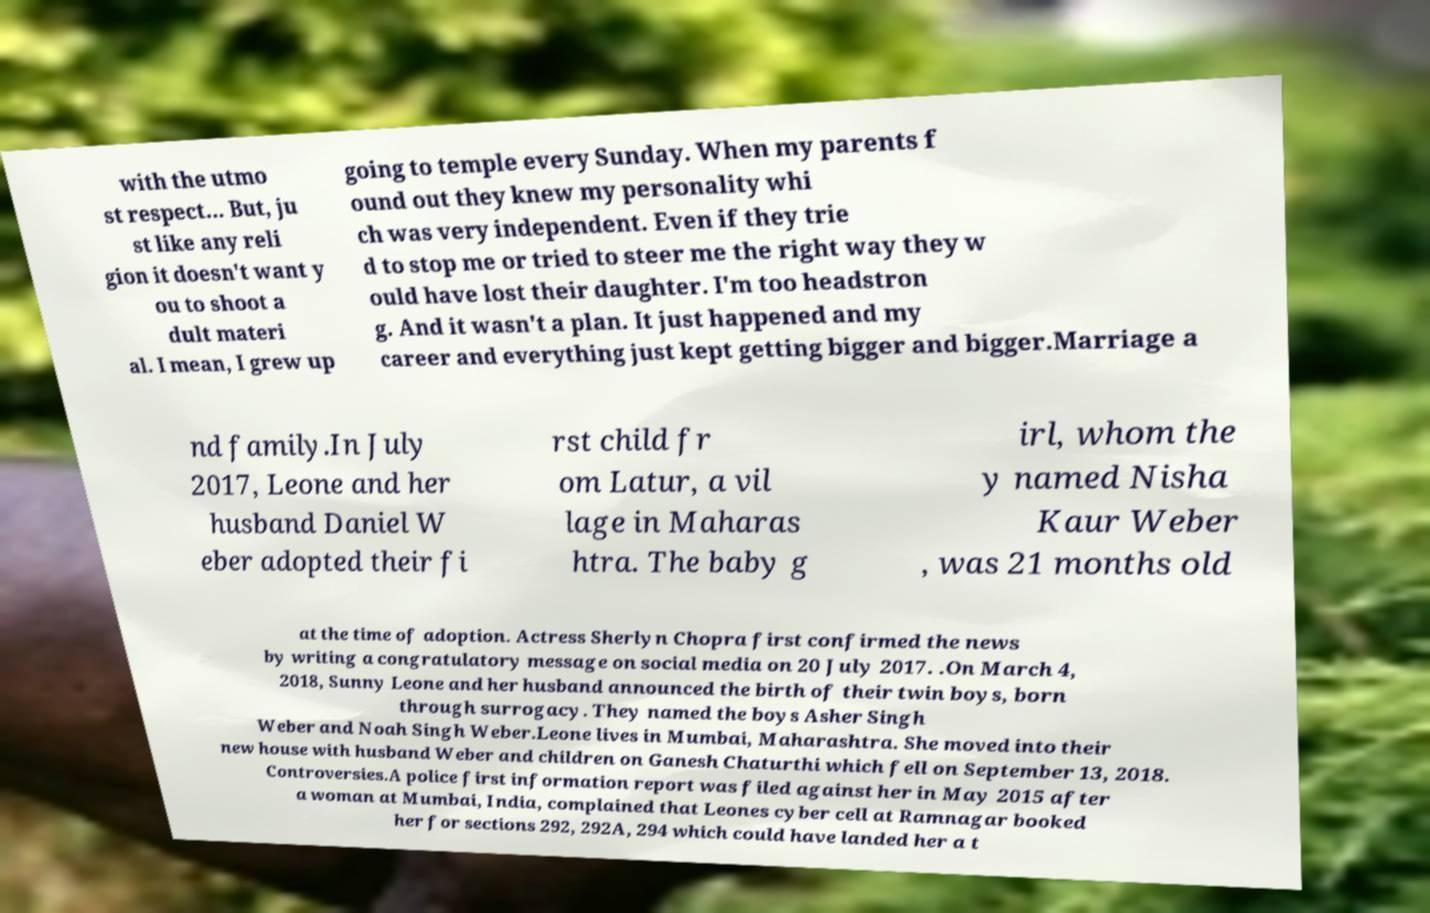There's text embedded in this image that I need extracted. Can you transcribe it verbatim? with the utmo st respect... But, ju st like any reli gion it doesn't want y ou to shoot a dult materi al. I mean, I grew up going to temple every Sunday. When my parents f ound out they knew my personality whi ch was very independent. Even if they trie d to stop me or tried to steer me the right way they w ould have lost their daughter. I'm too headstron g. And it wasn't a plan. It just happened and my career and everything just kept getting bigger and bigger.Marriage a nd family.In July 2017, Leone and her husband Daniel W eber adopted their fi rst child fr om Latur, a vil lage in Maharas htra. The baby g irl, whom the y named Nisha Kaur Weber , was 21 months old at the time of adoption. Actress Sherlyn Chopra first confirmed the news by writing a congratulatory message on social media on 20 July 2017. .On March 4, 2018, Sunny Leone and her husband announced the birth of their twin boys, born through surrogacy. They named the boys Asher Singh Weber and Noah Singh Weber.Leone lives in Mumbai, Maharashtra. She moved into their new house with husband Weber and children on Ganesh Chaturthi which fell on September 13, 2018. Controversies.A police first information report was filed against her in May 2015 after a woman at Mumbai, India, complained that Leones cyber cell at Ramnagar booked her for sections 292, 292A, 294 which could have landed her a t 